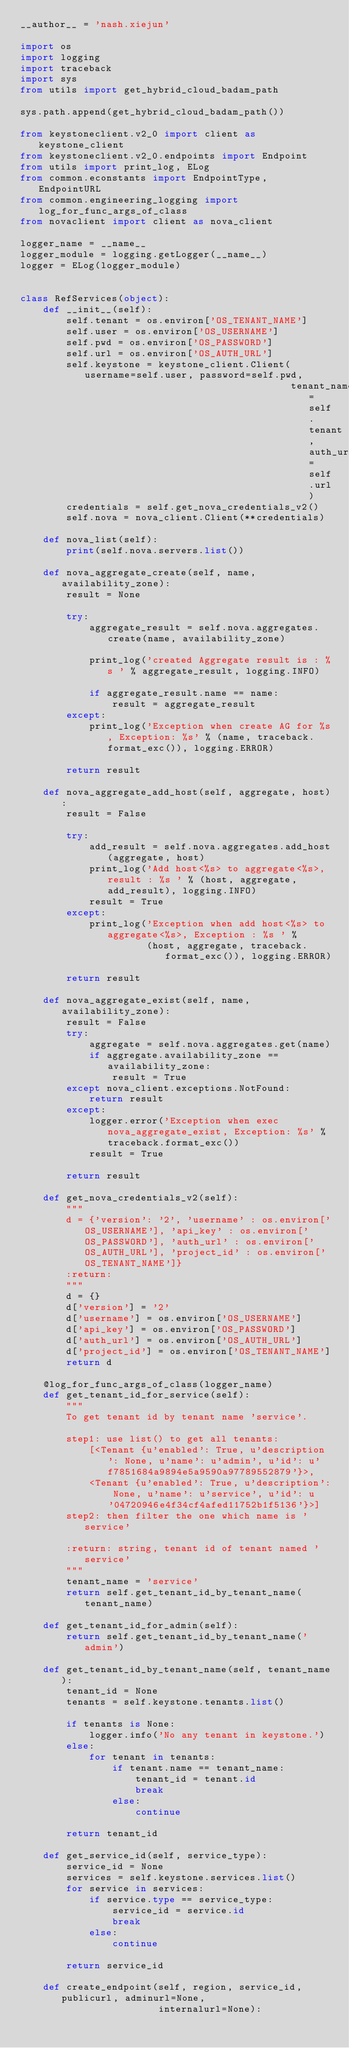Convert code to text. <code><loc_0><loc_0><loc_500><loc_500><_Python_>__author__ = 'nash.xiejun'

import os
import logging
import traceback
import sys
from utils import get_hybrid_cloud_badam_path

sys.path.append(get_hybrid_cloud_badam_path())

from keystoneclient.v2_0 import client as keystone_client
from keystoneclient.v2_0.endpoints import Endpoint
from utils import print_log, ELog
from common.econstants import EndpointType, EndpointURL
from common.engineering_logging import log_for_func_args_of_class
from novaclient import client as nova_client

logger_name = __name__
logger_module = logging.getLogger(__name__)
logger = ELog(logger_module)


class RefServices(object):
    def __init__(self):
        self.tenant = os.environ['OS_TENANT_NAME']
        self.user = os.environ['OS_USERNAME']
        self.pwd = os.environ['OS_PASSWORD']
        self.url = os.environ['OS_AUTH_URL']
        self.keystone = keystone_client.Client(username=self.user, password=self.pwd,
                                               tenant_name=self.tenant, auth_url=self.url)
        credentials = self.get_nova_credentials_v2()
        self.nova = nova_client.Client(**credentials)

    def nova_list(self):
        print(self.nova.servers.list())

    def nova_aggregate_create(self, name, availability_zone):
        result = None

        try:
            aggregate_result = self.nova.aggregates.create(name, availability_zone)

            print_log('created Aggregate result is : %s ' % aggregate_result, logging.INFO)

            if aggregate_result.name == name:
                result = aggregate_result
        except:
            print_log('Exception when create AG for %s, Exception: %s' % (name, traceback.format_exc()), logging.ERROR)

        return result

    def nova_aggregate_add_host(self, aggregate, host):
        result = False

        try:
            add_result = self.nova.aggregates.add_host(aggregate, host)
            print_log('Add host<%s> to aggregate<%s>, result : %s ' % (host, aggregate, add_result), logging.INFO)
            result = True
        except:
            print_log('Exception when add host<%s> to aggregate<%s>, Exception : %s ' %
                      (host, aggregate, traceback.format_exc()), logging.ERROR)

        return result

    def nova_aggregate_exist(self, name, availability_zone):
        result = False
        try:
            aggregate = self.nova.aggregates.get(name)
            if aggregate.availability_zone == availability_zone:
                result = True
        except nova_client.exceptions.NotFound:
            return result
        except:
            logger.error('Exception when exec nova_aggregate_exist, Exception: %s' % traceback.format_exc())
            result = True

        return result

    def get_nova_credentials_v2(self):
        """
        d = {'version': '2', 'username' : os.environ['OS_USERNAME'], 'api_key' : os.environ['OS_PASSWORD'], 'auth_url' : os.environ['OS_AUTH_URL'], 'project_id' : os.environ['OS_TENANT_NAME']}
        :return:
        """
        d = {}
        d['version'] = '2'
        d['username'] = os.environ['OS_USERNAME']
        d['api_key'] = os.environ['OS_PASSWORD']
        d['auth_url'] = os.environ['OS_AUTH_URL']
        d['project_id'] = os.environ['OS_TENANT_NAME']
        return d

    @log_for_func_args_of_class(logger_name)
    def get_tenant_id_for_service(self):
        """
        To get tenant id by tenant name 'service'.

        step1: use list() to get all tenants:
            [<Tenant {u'enabled': True, u'description': None, u'name': u'admin', u'id': u'f7851684a9894e5a9590a97789552879'}>,
            <Tenant {u'enabled': True, u'description': None, u'name': u'service', u'id': u'04720946e4f34cf4afed11752b1f5136'}>]
        step2: then filter the one which name is 'service'

        :return: string, tenant id of tenant named 'service'
        """
        tenant_name = 'service'
        return self.get_tenant_id_by_tenant_name(tenant_name)

    def get_tenant_id_for_admin(self):
        return self.get_tenant_id_by_tenant_name('admin')

    def get_tenant_id_by_tenant_name(self, tenant_name):
        tenant_id = None
        tenants = self.keystone.tenants.list()

        if tenants is None:
            logger.info('No any tenant in keystone.')
        else:
            for tenant in tenants:
                if tenant.name == tenant_name:
                    tenant_id = tenant.id
                    break
                else:
                    continue

        return tenant_id

    def get_service_id(self, service_type):
        service_id = None
        services = self.keystone.services.list()
        for service in services:
            if service.type == service_type:
                service_id = service.id
                break
            else:
                continue

        return service_id

    def create_endpoint(self, region, service_id, publicurl, adminurl=None,
                        internalurl=None):</code> 